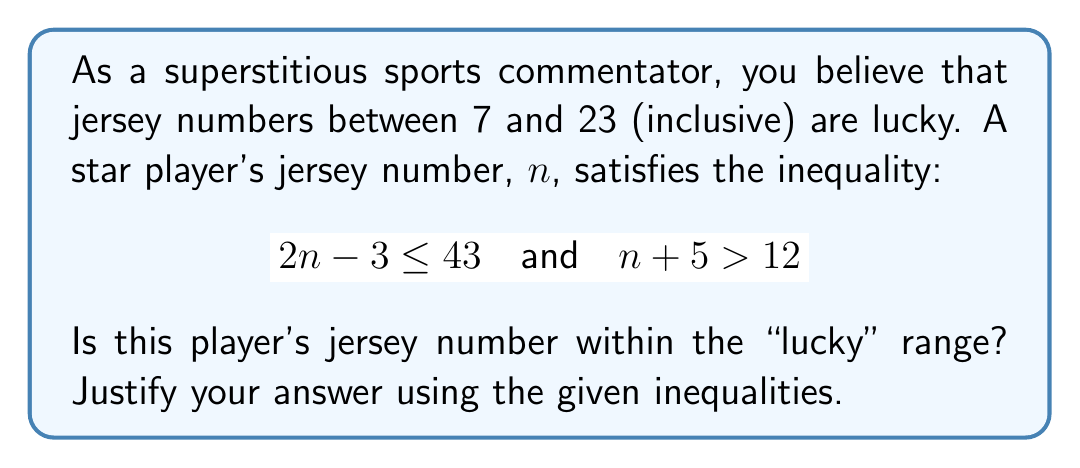Show me your answer to this math problem. Let's approach this step-by-step:

1) We have two inequalities to work with:
   $$ 2n - 3 \leq 43 \quad \text{and} \quad n + 5 > 12 $$

2) Let's solve the first inequality:
   $$ 2n - 3 \leq 43 $$
   $$ 2n \leq 46 $$
   $$ n \leq 23 $$

3) Now, let's solve the second inequality:
   $$ n + 5 > 12 $$
   $$ n > 7 $$

4) Combining these results, we can say that $n$ is greater than 7 and less than or equal to 23:
   $$ 7 < n \leq 23 $$

5) The "lucky" range is defined as numbers between 7 and 23, inclusive. This can be written as:
   $$ 7 \leq n \leq 23 $$

6) Comparing our result from step 4 with the lucky range, we can see that the player's number satisfies the lucky range condition, as it's greater than 7 and less than or equal to 23.

Therefore, the player's jersey number is indeed within the "lucky" range.
Answer: Yes, the player's jersey number is within the "lucky" range of 7 to 23 (inclusive). 